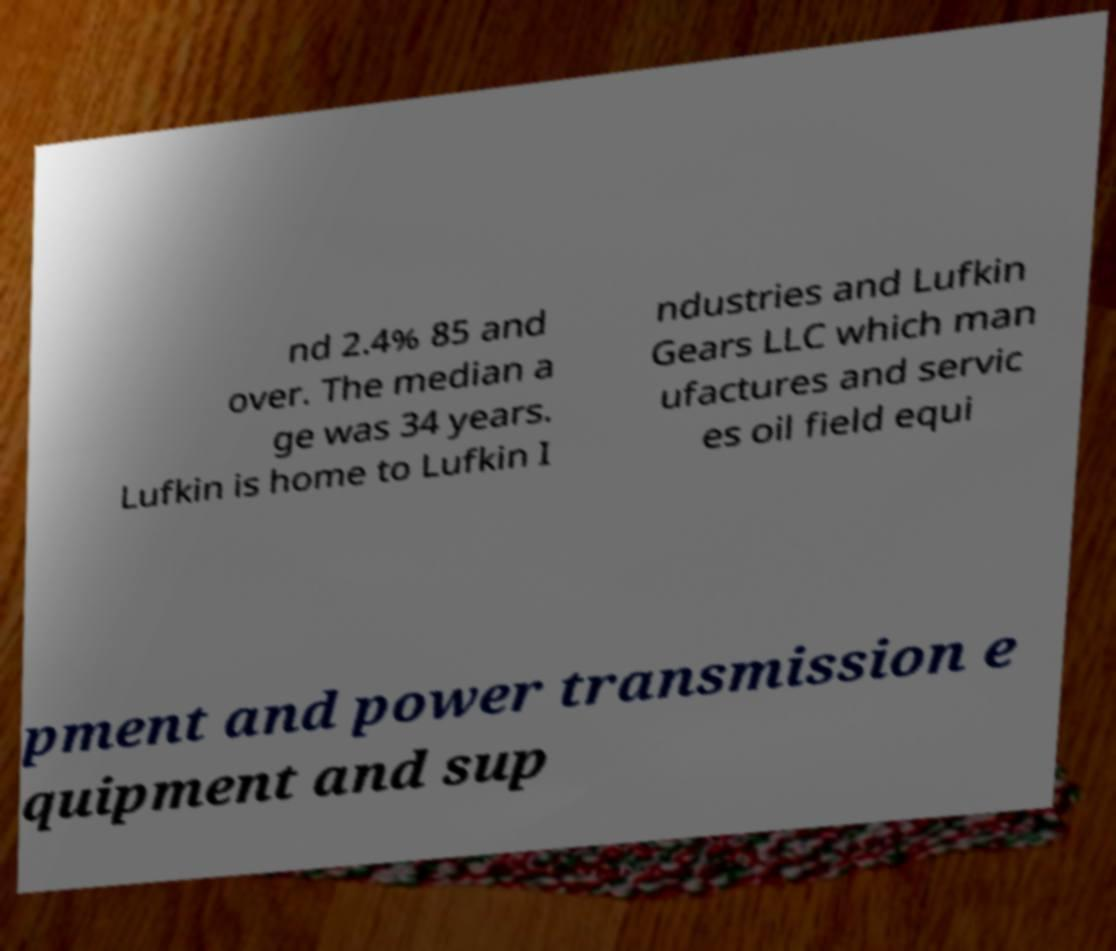Please read and relay the text visible in this image. What does it say? nd 2.4% 85 and over. The median a ge was 34 years. Lufkin is home to Lufkin I ndustries and Lufkin Gears LLC which man ufactures and servic es oil field equi pment and power transmission e quipment and sup 